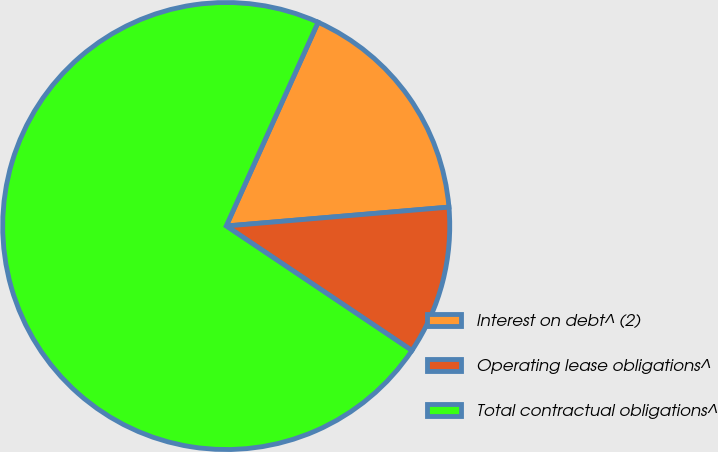<chart> <loc_0><loc_0><loc_500><loc_500><pie_chart><fcel>Interest on debt^ (2)<fcel>Operating lease obligations^<fcel>Total contractual obligations^<nl><fcel>16.91%<fcel>10.75%<fcel>72.34%<nl></chart> 